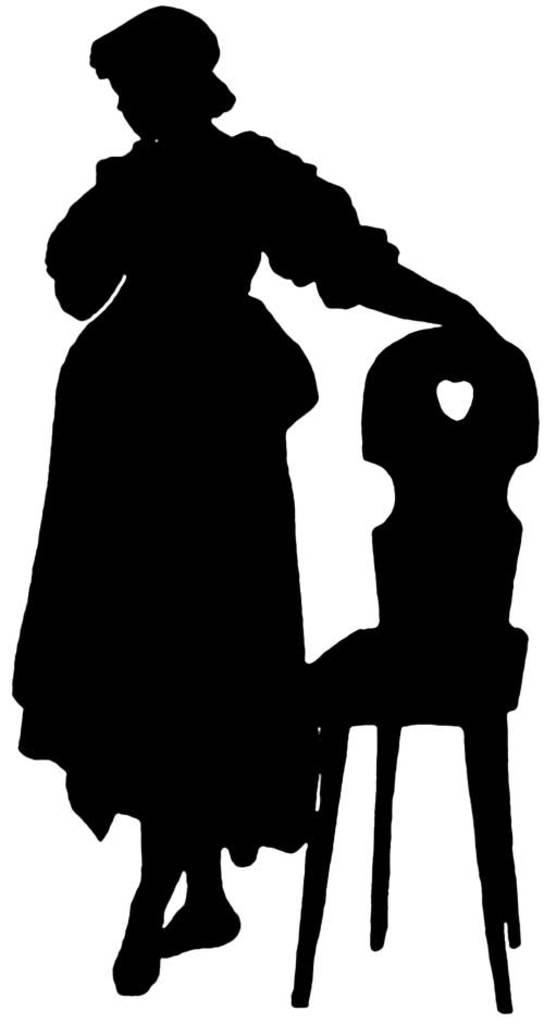What is depicted in the painting in the image? There is a painting of a lady in the image. What color is the chair in the painting? The chair in the painting has a black color. What color is the background of the painting? The background of the painting is white. Can you see a yoke in the painting? There is no yoke present in the painting; it features a lady and a chair with a black color against a white background. 